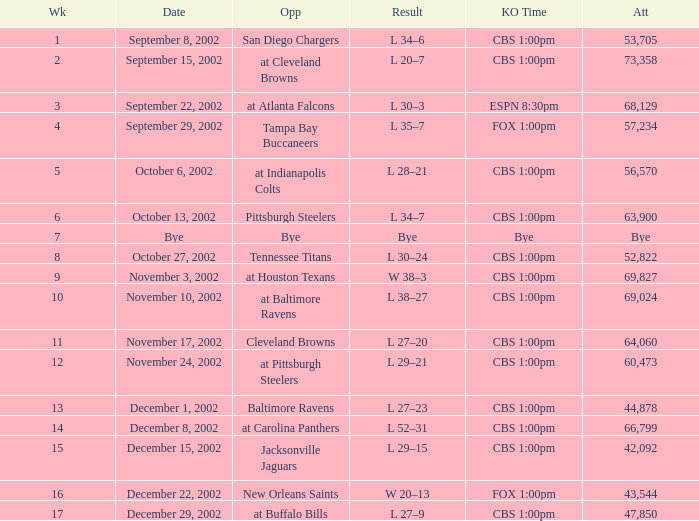How many people attended the game with a kickoff time of cbs 1:00pm, in a week earlier than 8, on September 15, 2002? 73358.0. 